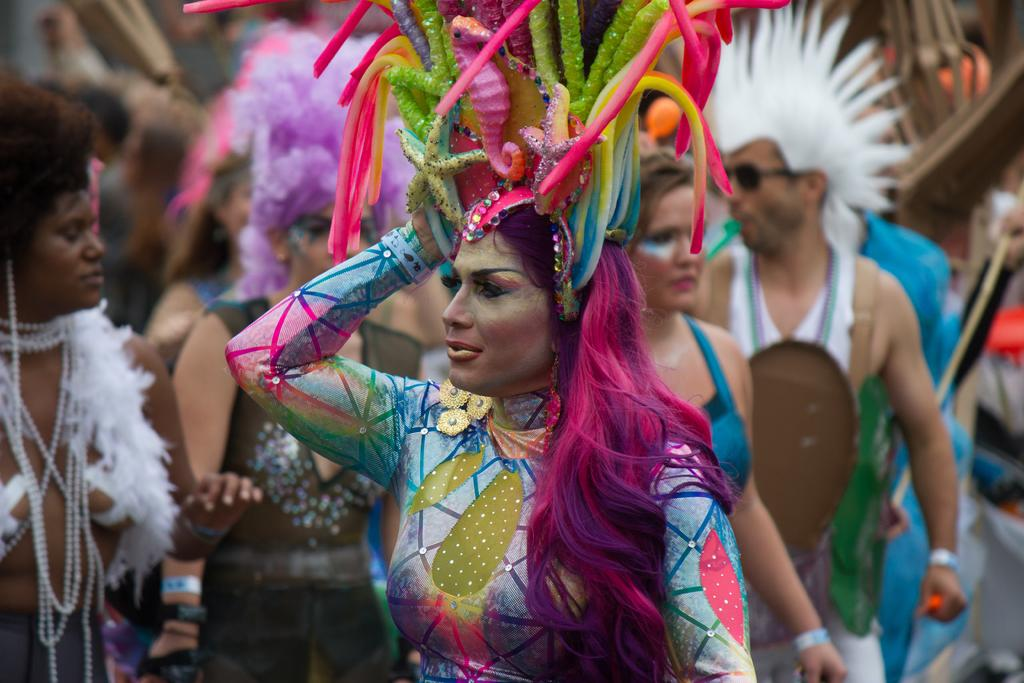What types of people are present in the image? There are women and men in the image. What are the people in the image wearing? The people in the image are wearing different costumes. Can you tell me how many people are swinging in the image? There is no reference to anyone swinging in the image. 